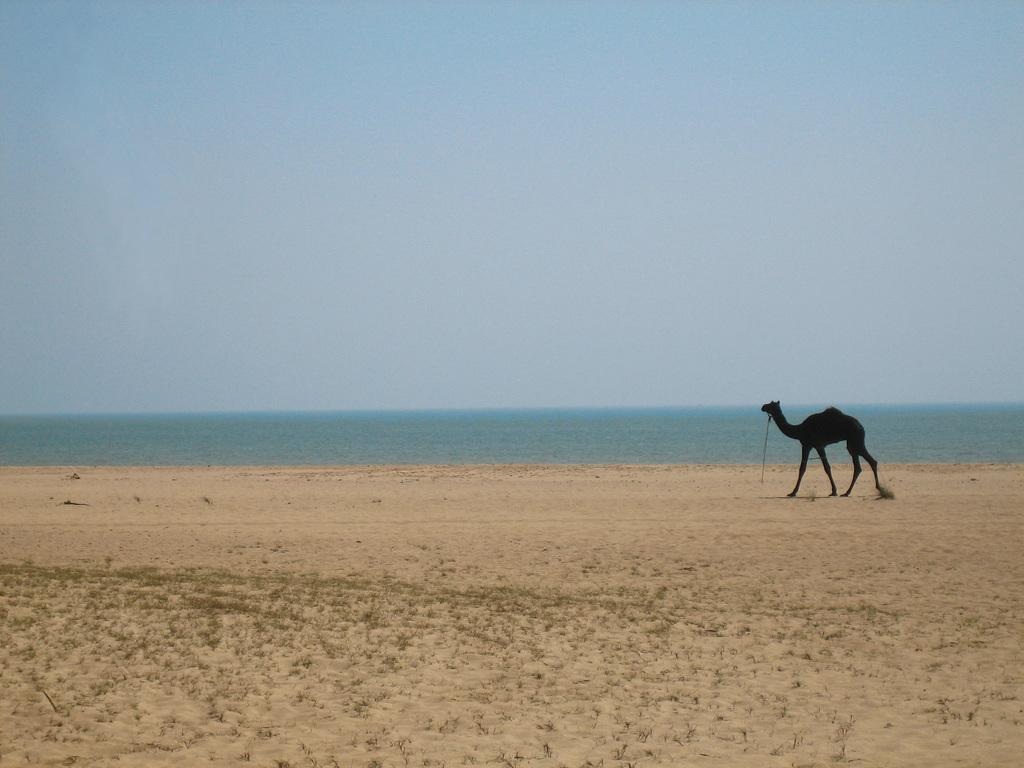What type of terrain is depicted in the image? The image contains soil and grass. What animal can be seen in the image? There is a camel in the image. Is there any water visible in the image? Yes, there is water visible in the image. What is the color of the sky in the image? The sky is blue in the image. How does the camel attract attention at the airport in the image? There is no airport present in the image, and therefore no camel to attract attention. 